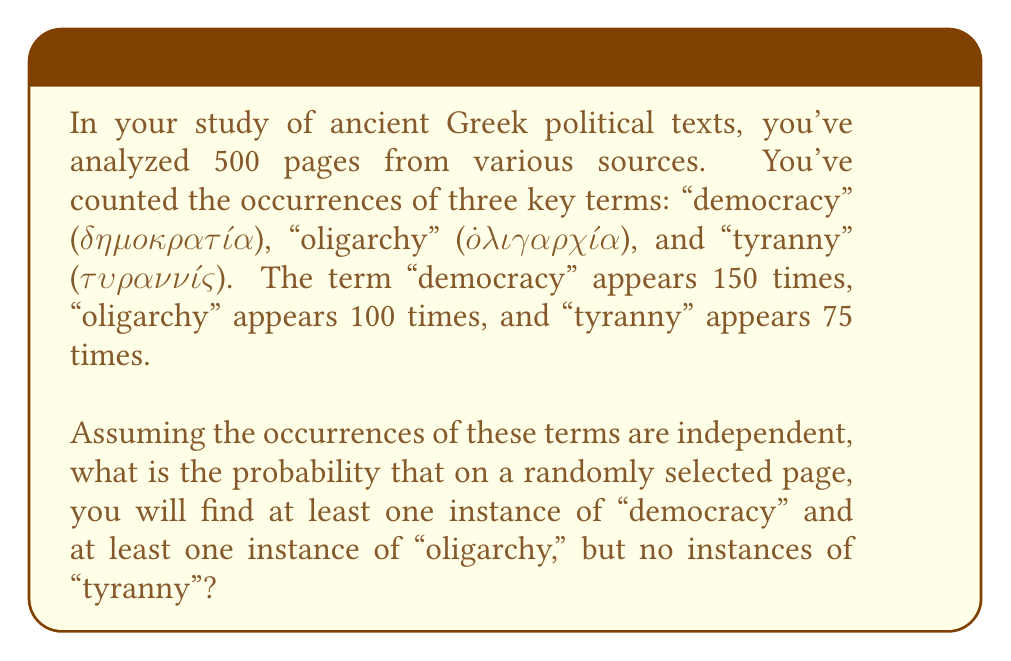Can you answer this question? Let's approach this step-by-step:

1) First, we need to calculate the probability of each term appearing on a single page:

   P(democracy) = $\frac{150}{500} = 0.3$
   P(oligarchy) = $\frac{100}{500} = 0.2$
   P(tyranny) = $\frac{75}{500} = 0.15$

2) Now, we need to find the probability of:
   - At least one "democracy" AND
   - At least one "oligarchy" AND
   - No "tyranny"

3) We can calculate this as:
   P(at least one democracy) × P(at least one oligarchy) × P(no tyranny)

4) P(at least one democracy) = 1 - P(no democracy) = $1 - (1 - 0.3) = 0.3$

5) P(at least one oligarchy) = 1 - P(no oligarchy) = $1 - (1 - 0.2) = 0.2$

6) P(no tyranny) = $1 - 0.15 = 0.85$

7) Therefore, the probability we're looking for is:
   $$0.3 \times 0.2 \times 0.85 = 0.051$$

Thus, the probability is 0.051 or 5.1%.
Answer: 0.051 or 5.1% 